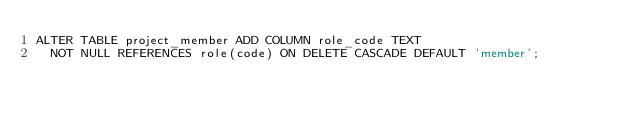Convert code to text. <code><loc_0><loc_0><loc_500><loc_500><_SQL_>ALTER TABLE project_member ADD COLUMN role_code TEXT
  NOT NULL REFERENCES role(code) ON DELETE CASCADE DEFAULT 'member';
</code> 